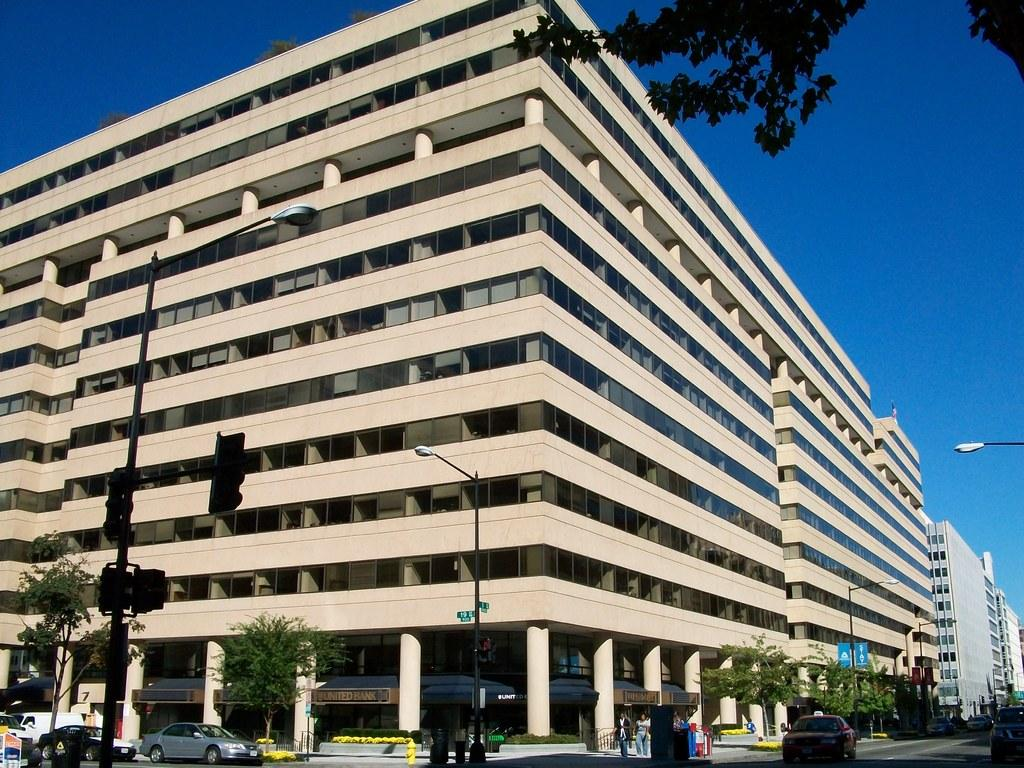What type of structures can be seen in the image? There are buildings in the image. What are the tall, vertical objects in the image? Light poles are present in the image. What type of natural elements are visible in the image? Trees are visible in the image. What type of transportation is on the road in the image? Vehicles are on the road in the image. What type of information is displayed on the boards in the image? There are sign boards in the image. What color is the sky in the image? The sky is blue in the image. Can you see any slopes or steep inclines in the image? There is no mention of slopes or steep inclines in the image; it only features buildings, light poles, trees, vehicles, sign boards, and a blue sky. How many feet are visible in the image? There is no mention of feet or any body parts in the image; it only features inanimate objects and the sky. 